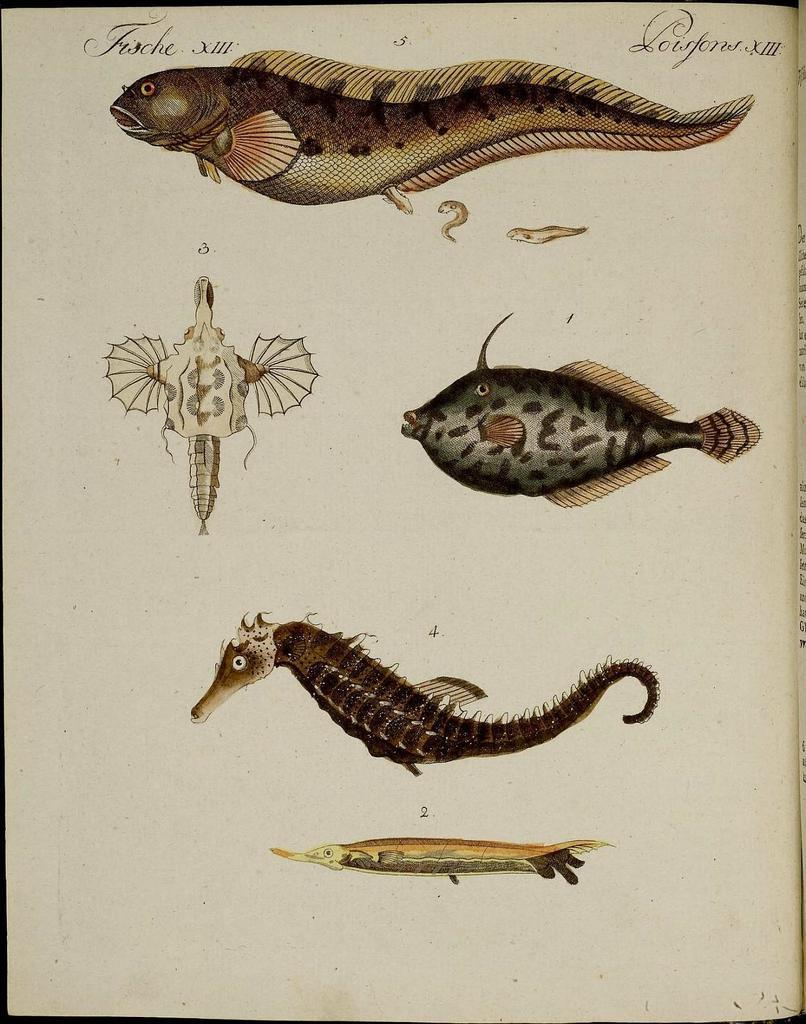What type of medium is the image? The image is a page. What is depicted on the page? There are fishes depicted on the page. What else can be found on the page besides the fishes? There is text present on the page. Where is the stop sign located on the page? There is no stop sign present on the page; it features fishes and text. What type of structure can be seen crossing the bridge in the image? There is no bridge present in the image; it only features fishes and text on a page. 